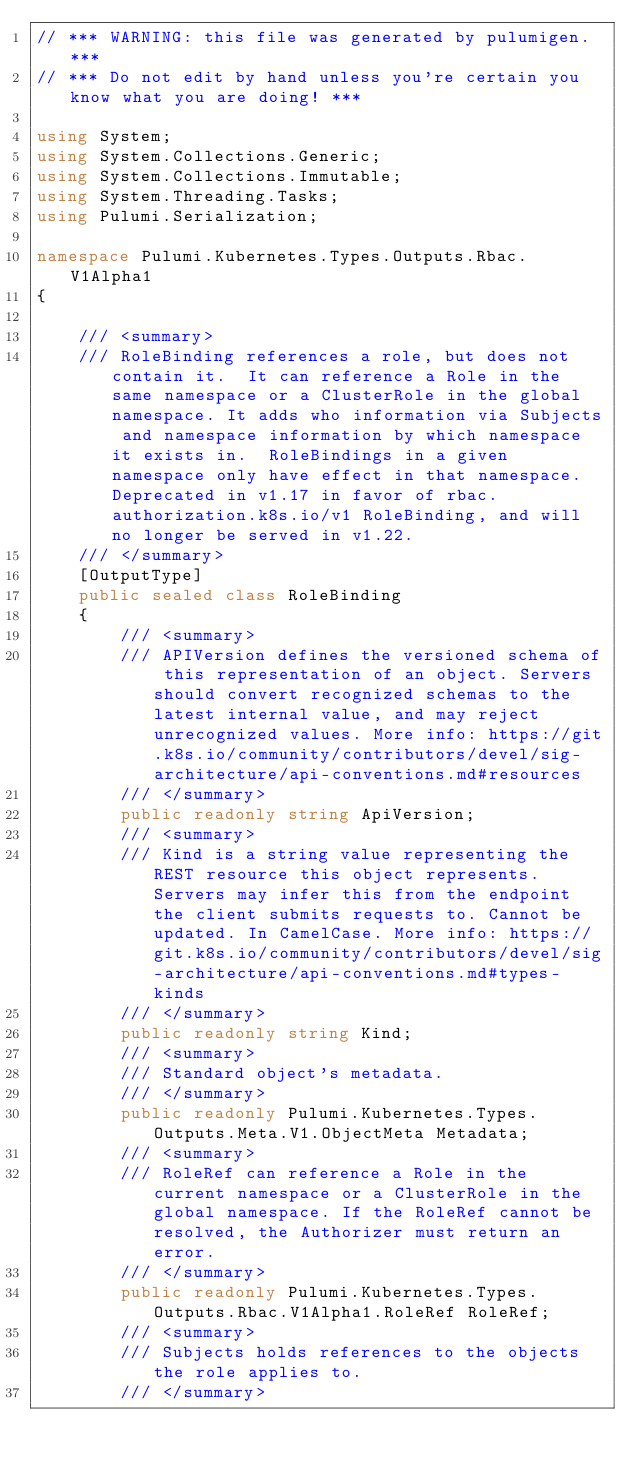Convert code to text. <code><loc_0><loc_0><loc_500><loc_500><_C#_>// *** WARNING: this file was generated by pulumigen. ***
// *** Do not edit by hand unless you're certain you know what you are doing! ***

using System;
using System.Collections.Generic;
using System.Collections.Immutable;
using System.Threading.Tasks;
using Pulumi.Serialization;

namespace Pulumi.Kubernetes.Types.Outputs.Rbac.V1Alpha1
{

    /// <summary>
    /// RoleBinding references a role, but does not contain it.  It can reference a Role in the same namespace or a ClusterRole in the global namespace. It adds who information via Subjects and namespace information by which namespace it exists in.  RoleBindings in a given namespace only have effect in that namespace. Deprecated in v1.17 in favor of rbac.authorization.k8s.io/v1 RoleBinding, and will no longer be served in v1.22.
    /// </summary>
    [OutputType]
    public sealed class RoleBinding
    {
        /// <summary>
        /// APIVersion defines the versioned schema of this representation of an object. Servers should convert recognized schemas to the latest internal value, and may reject unrecognized values. More info: https://git.k8s.io/community/contributors/devel/sig-architecture/api-conventions.md#resources
        /// </summary>
        public readonly string ApiVersion;
        /// <summary>
        /// Kind is a string value representing the REST resource this object represents. Servers may infer this from the endpoint the client submits requests to. Cannot be updated. In CamelCase. More info: https://git.k8s.io/community/contributors/devel/sig-architecture/api-conventions.md#types-kinds
        /// </summary>
        public readonly string Kind;
        /// <summary>
        /// Standard object's metadata.
        /// </summary>
        public readonly Pulumi.Kubernetes.Types.Outputs.Meta.V1.ObjectMeta Metadata;
        /// <summary>
        /// RoleRef can reference a Role in the current namespace or a ClusterRole in the global namespace. If the RoleRef cannot be resolved, the Authorizer must return an error.
        /// </summary>
        public readonly Pulumi.Kubernetes.Types.Outputs.Rbac.V1Alpha1.RoleRef RoleRef;
        /// <summary>
        /// Subjects holds references to the objects the role applies to.
        /// </summary></code> 